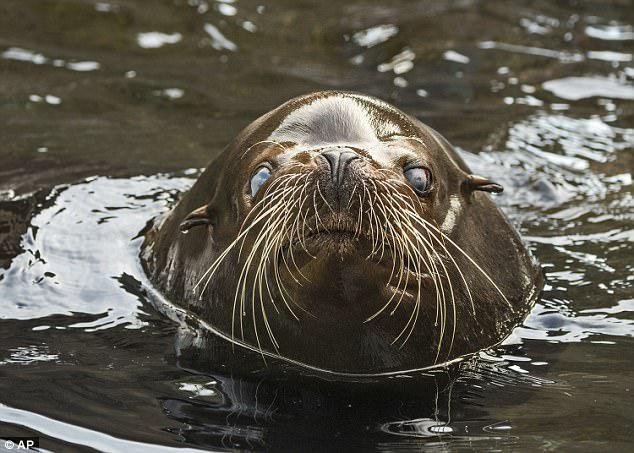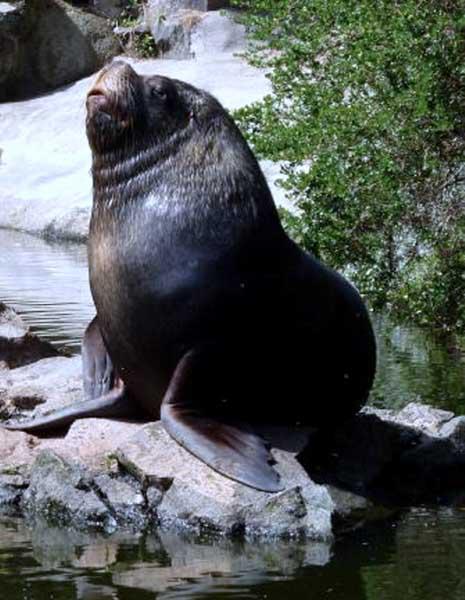The first image is the image on the left, the second image is the image on the right. Considering the images on both sides, is "a single animal is on a rock in the right pic" valid? Answer yes or no. Yes. The first image is the image on the left, the second image is the image on the right. Examine the images to the left and right. Is the description "In one image, a seal is in the water." accurate? Answer yes or no. Yes. 